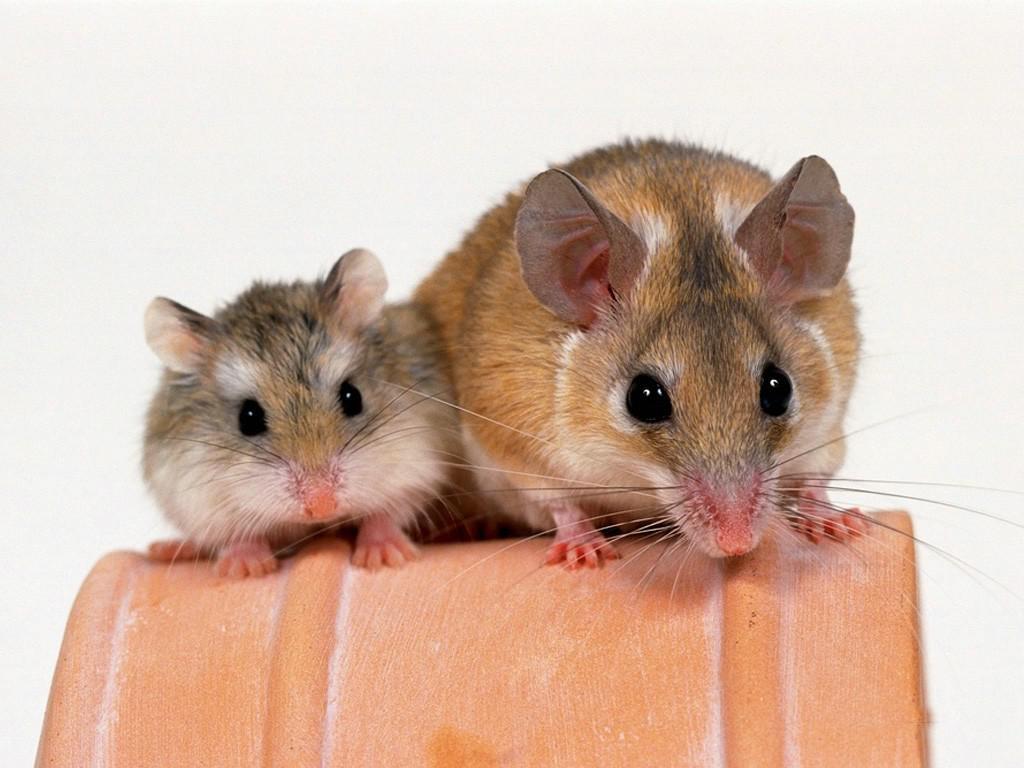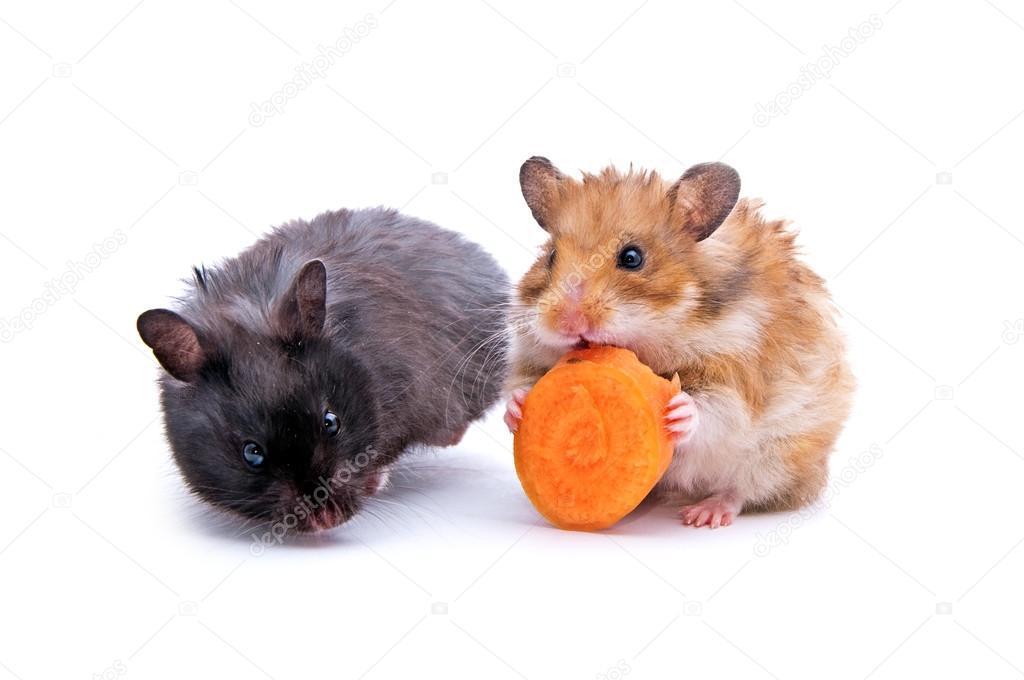The first image is the image on the left, the second image is the image on the right. Analyze the images presented: Is the assertion "At least one hamster is eating a piece of carrot." valid? Answer yes or no. Yes. The first image is the image on the left, the second image is the image on the right. Examine the images to the left and right. Is the description "None of these rodents is snacking on a carrot slice." accurate? Answer yes or no. No. 